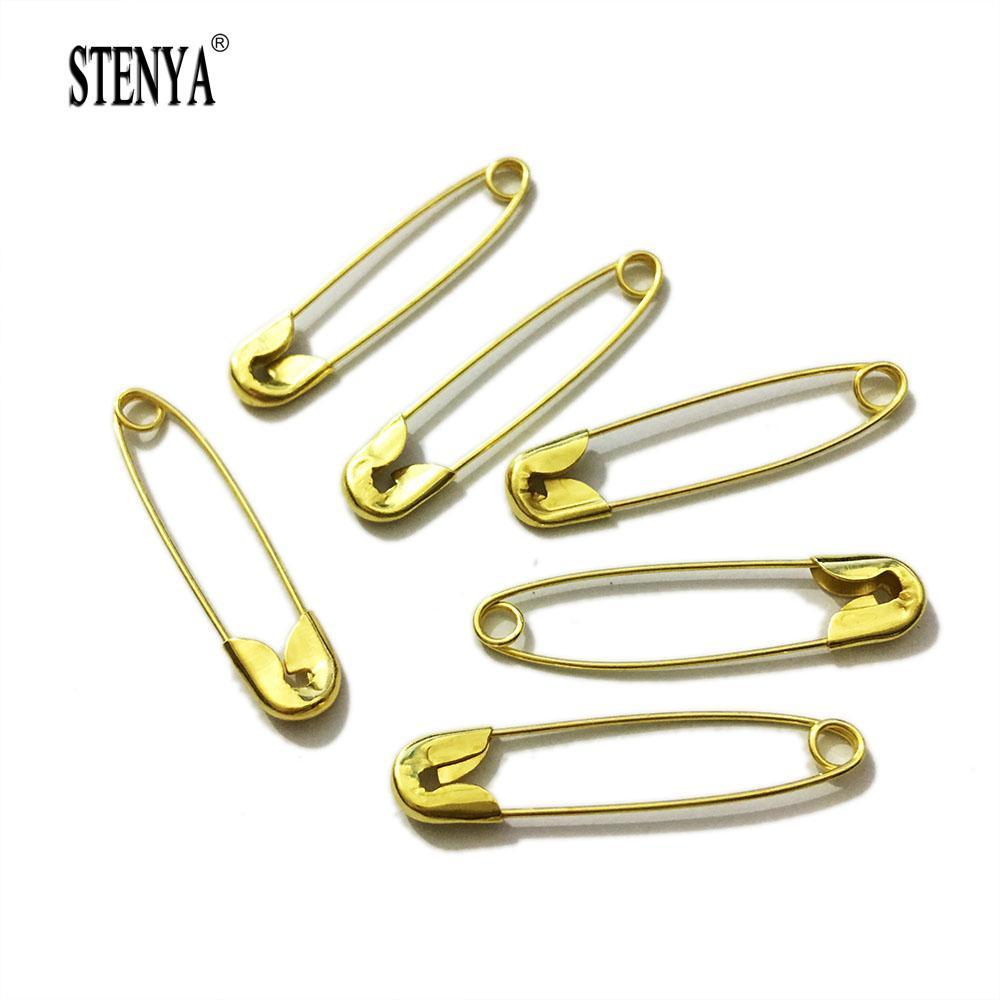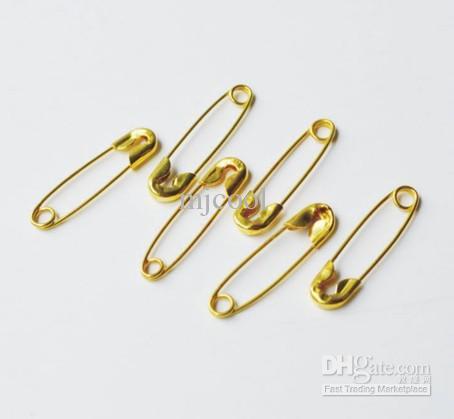The first image is the image on the left, the second image is the image on the right. Considering the images on both sides, is "Most of the fasteners are gold." valid? Answer yes or no. Yes. 